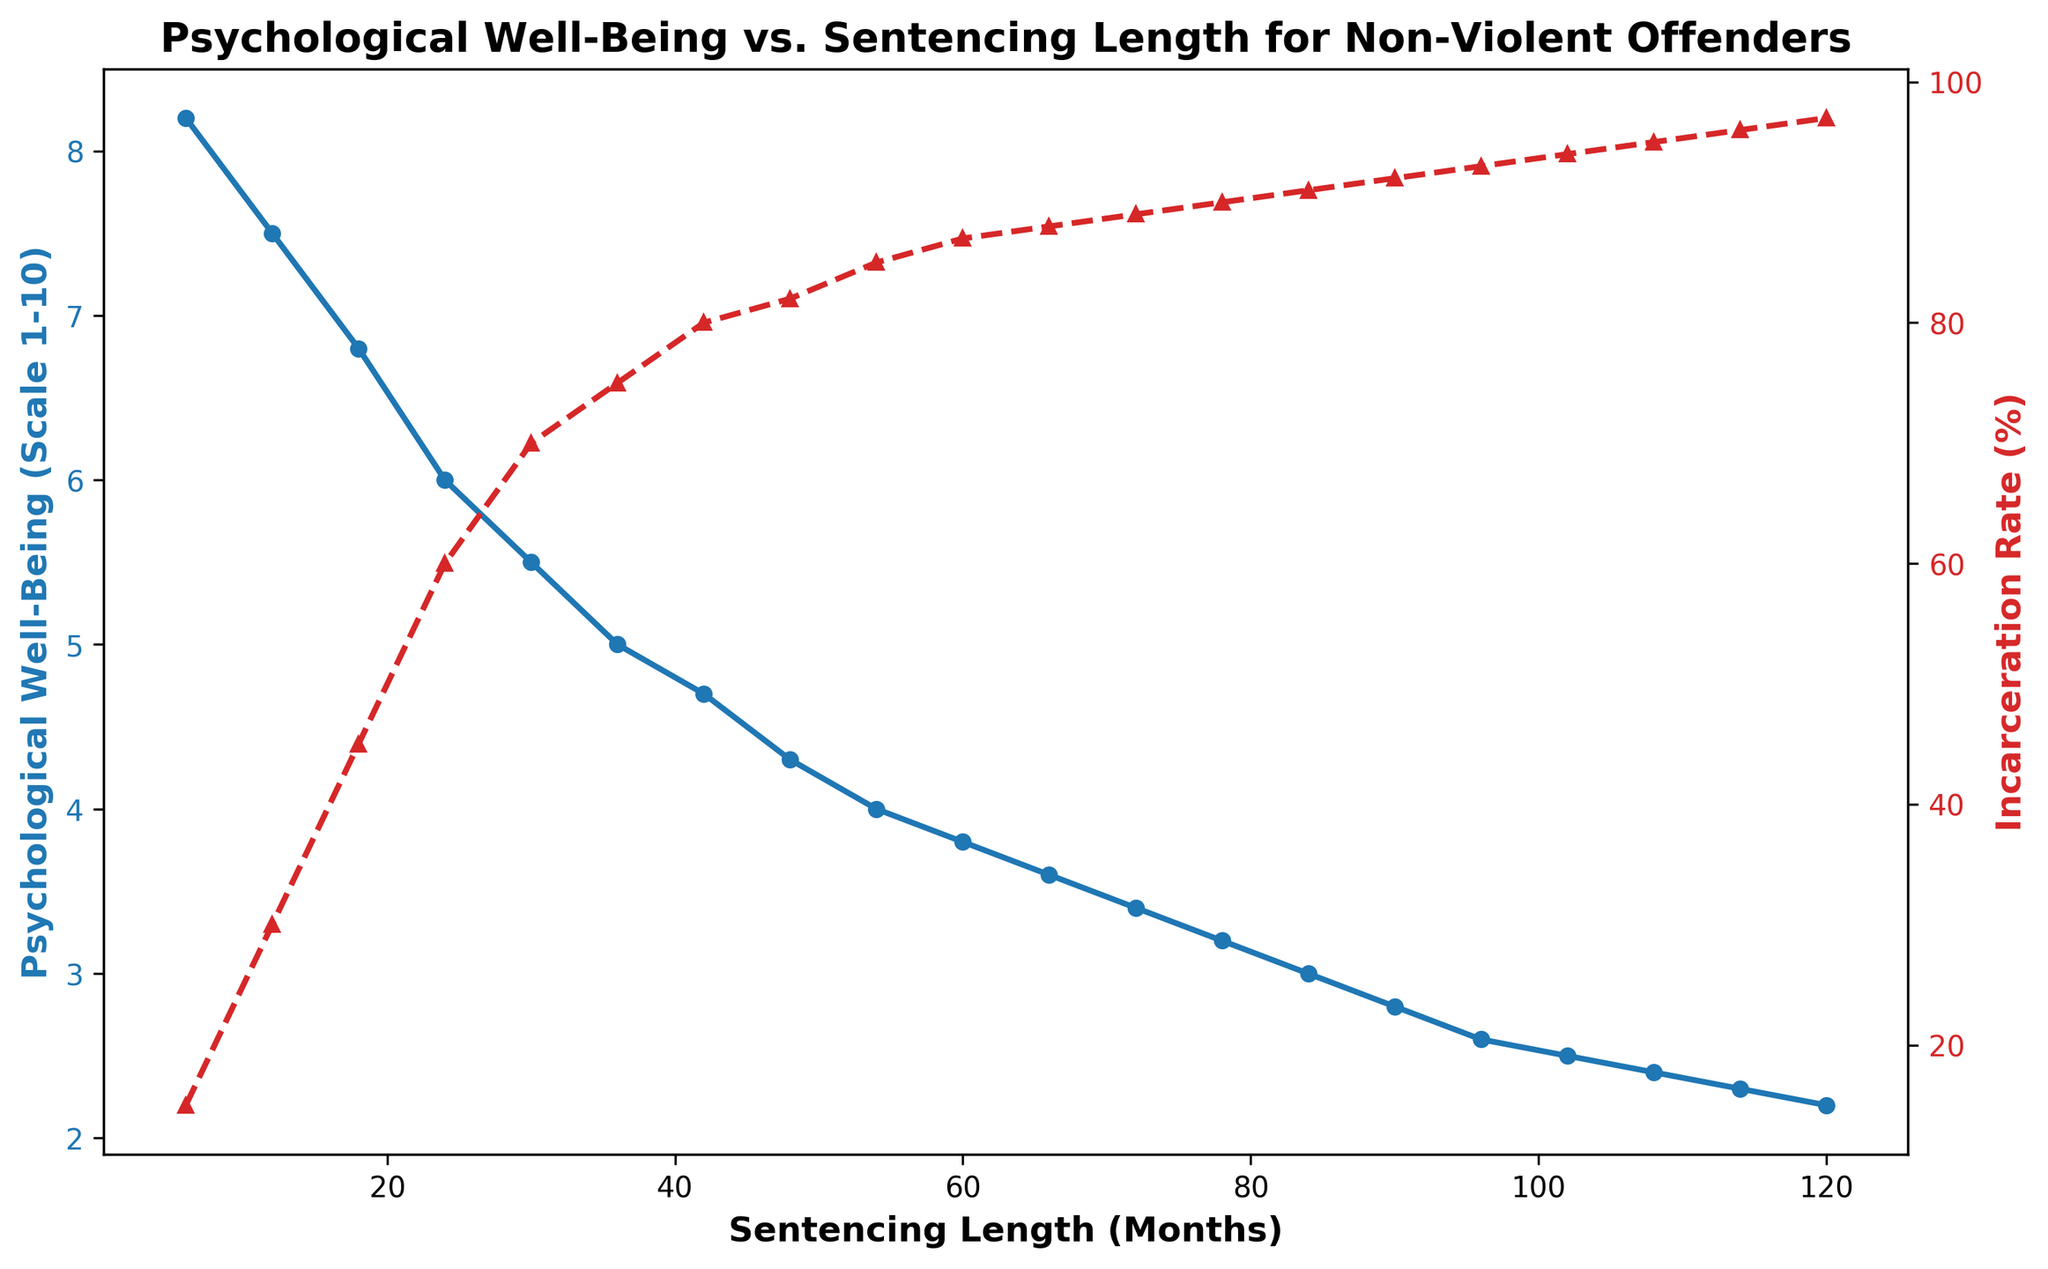What happens to the psychological well-being of non-violent offenders as the sentencing length increases from 6 to 60 months? Psychological well-being scores decrease from 8.2 to 3.8 as the sentencing length increases from 6 to 60 months.
Answer: Decreases Which variable increases more rapidly with sentencing length, psychological well-being or incarceration rate? Psychological well-being decreases while incarceration rate increases. Comparing their rates of change shows that incarceration rate increases more rapidly with sentencing length.
Answer: Incarceration rate At 36 months of sentencing, what values do the psychological well-being and incarceration rate reach? At 36 months, the psychological well-being score is 5.0 and the incarceration rate is 75%.
Answer: Psychological Well-Being: 5.0, Incarceration Rate: 75% What is the difference in psychological well-being between sentencing lengths of 48 and 72 months? Psychological well-being at 48 months is 4.3 and at 72 months is 3.4. The difference is 4.3 - 3.4 = 0.9.
Answer: 0.9 How does the psychological well-being change for every 12-month increase in sentencing after 24 months? For every 12-month increase after 24 months, the psychological well-being decreases by approximately 0.5 to 0.6 points.
Answer: Decreases by 0.5 to 0.6 points per 12 months Is there an instance where both the psychological well-being and incarceration rate are close to their respective extremes? At 120 months, the psychological well-being is near its lowest (2.2) while the incarceration rate is near its highest (97%).
Answer: Yes Which sentencing length corresponds to the highest psychological well-being? The highest psychological well-being of 8.2 is observed at the sentencing length of 6 months.
Answer: 6 months If the sentencing length is 84 months, what percentage of the population is incarcerated, and what is the psychological well-being score at this length? At 84 months, 91% of the population is incarcerated and the psychological well-being score is 3.0.
Answer: Incarceration Rate: 91%, Psychological Well-Being: 3.0 By how much does the incarceration rate increase between every 18-month interval from 6 months to 96 months? From 6 to 24 months, the increase is 15% (30% - 15%), from 24 to 42 months, the increase is 20% (60% - 40%), and so on. Generally, the rate increases around 15-20% per interval.
Answer: 15-20% Between which two sentencing lengths does the psychological well-being drop the most? The psychological well-being drops the most between 24 and 30 months, where it decreases from 6.0 to 5.5, a difference of 0.5 points.
Answer: 24-30 months 